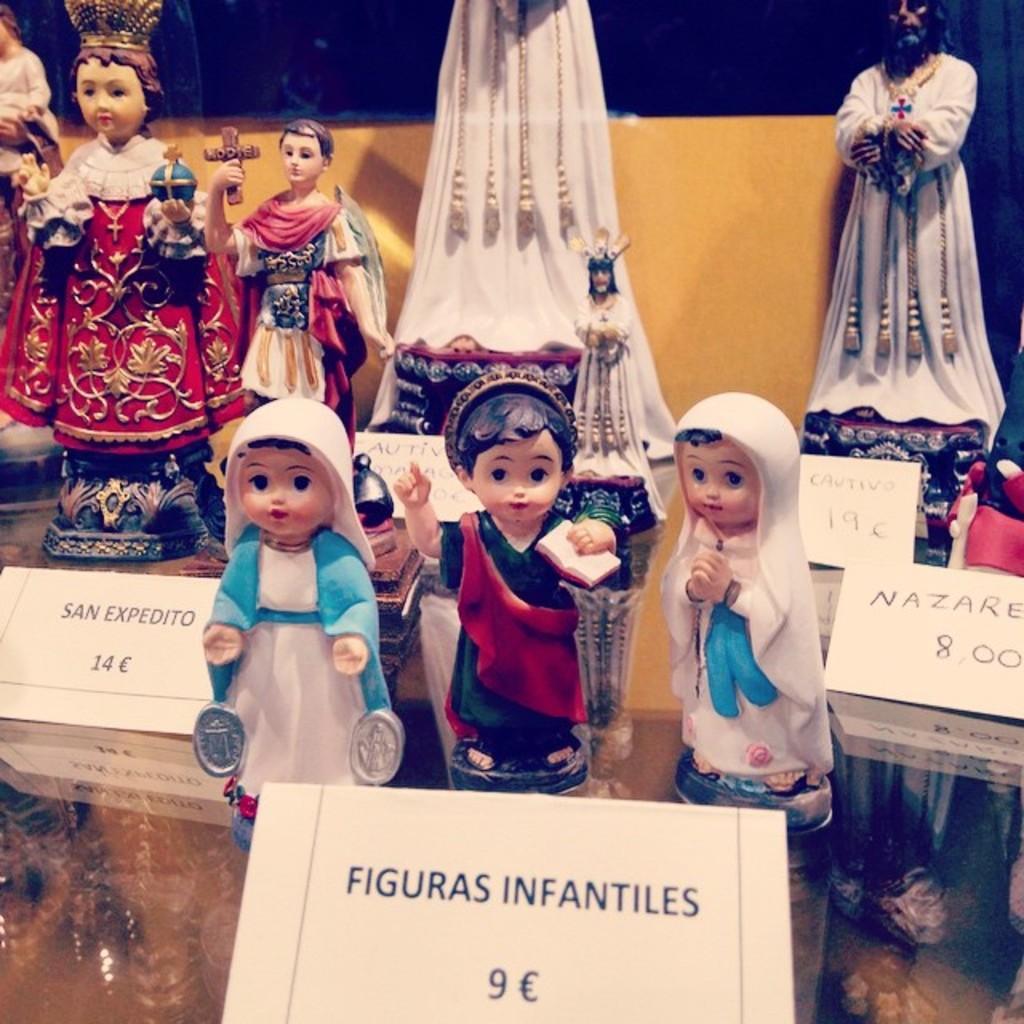Can you describe this image briefly? In this image in the front there is a paper with some text written on it. In the center there are dolls and there are papers with some text written on it. In the background there are statues and there is an object which is yellow in colour. 